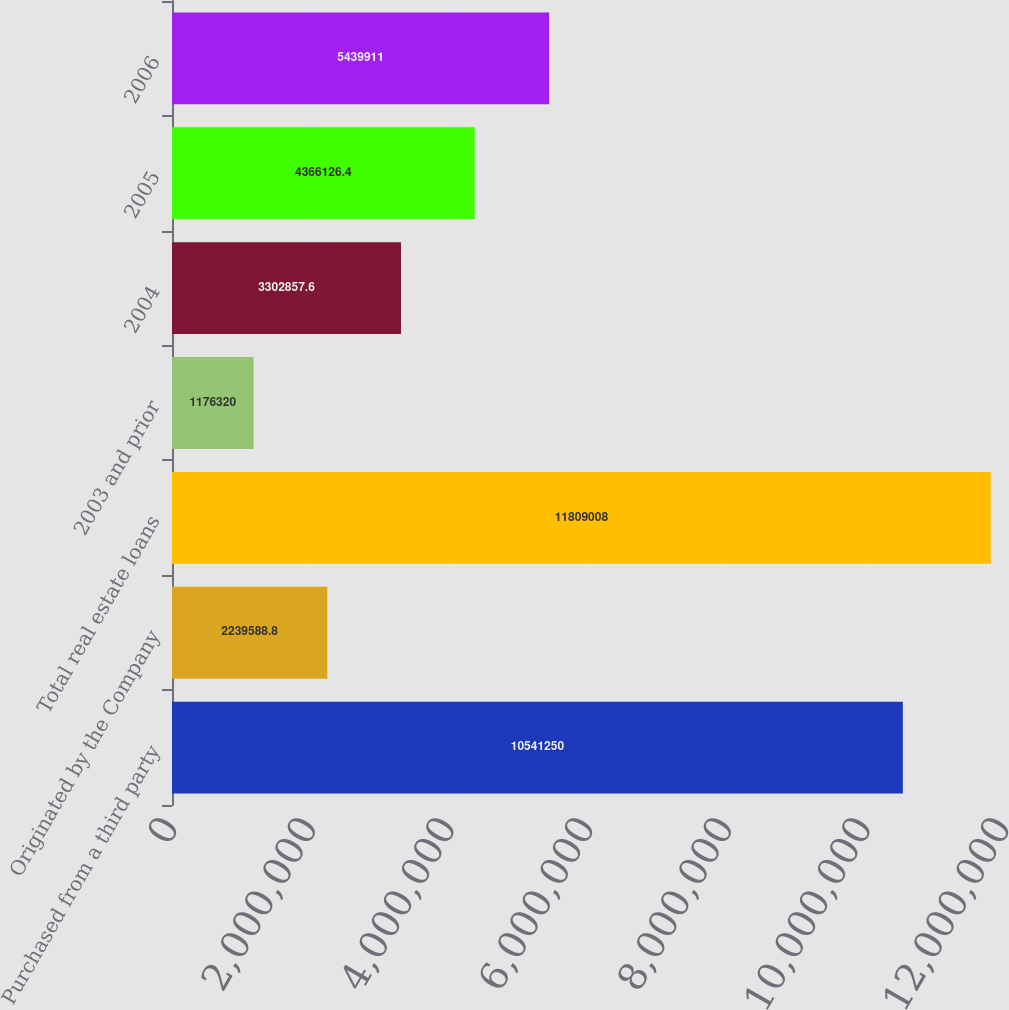Convert chart to OTSL. <chart><loc_0><loc_0><loc_500><loc_500><bar_chart><fcel>Purchased from a third party<fcel>Originated by the Company<fcel>Total real estate loans<fcel>2003 and prior<fcel>2004<fcel>2005<fcel>2006<nl><fcel>1.05412e+07<fcel>2.23959e+06<fcel>1.1809e+07<fcel>1.17632e+06<fcel>3.30286e+06<fcel>4.36613e+06<fcel>5.43991e+06<nl></chart> 